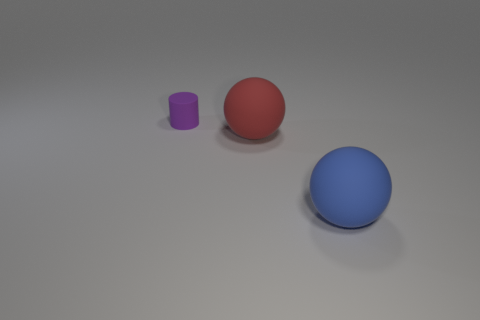There is a rubber sphere behind the big rubber thing in front of the big thing behind the blue thing; what color is it?
Offer a very short reply. Red. Is the number of big matte things that are behind the purple matte cylinder less than the number of big red matte spheres?
Your answer should be compact. Yes. There is a big rubber object behind the blue matte thing; is it the same shape as the big rubber thing that is to the right of the big red sphere?
Keep it short and to the point. Yes. How many things are either matte things to the left of the large blue matte object or red rubber things?
Make the answer very short. 2. There is a large sphere that is on the left side of the rubber sphere in front of the large red rubber object; is there a purple rubber cylinder in front of it?
Your response must be concise. No. Are there fewer big matte balls left of the small purple cylinder than balls to the right of the big blue thing?
Make the answer very short. No. There is another large sphere that is made of the same material as the big blue ball; what is its color?
Ensure brevity in your answer.  Red. There is a matte ball that is right of the big object behind the big blue thing; what is its color?
Your answer should be very brief. Blue. Is there a small rubber cube of the same color as the small rubber object?
Provide a short and direct response. No. The other thing that is the same size as the red thing is what shape?
Offer a terse response. Sphere. 